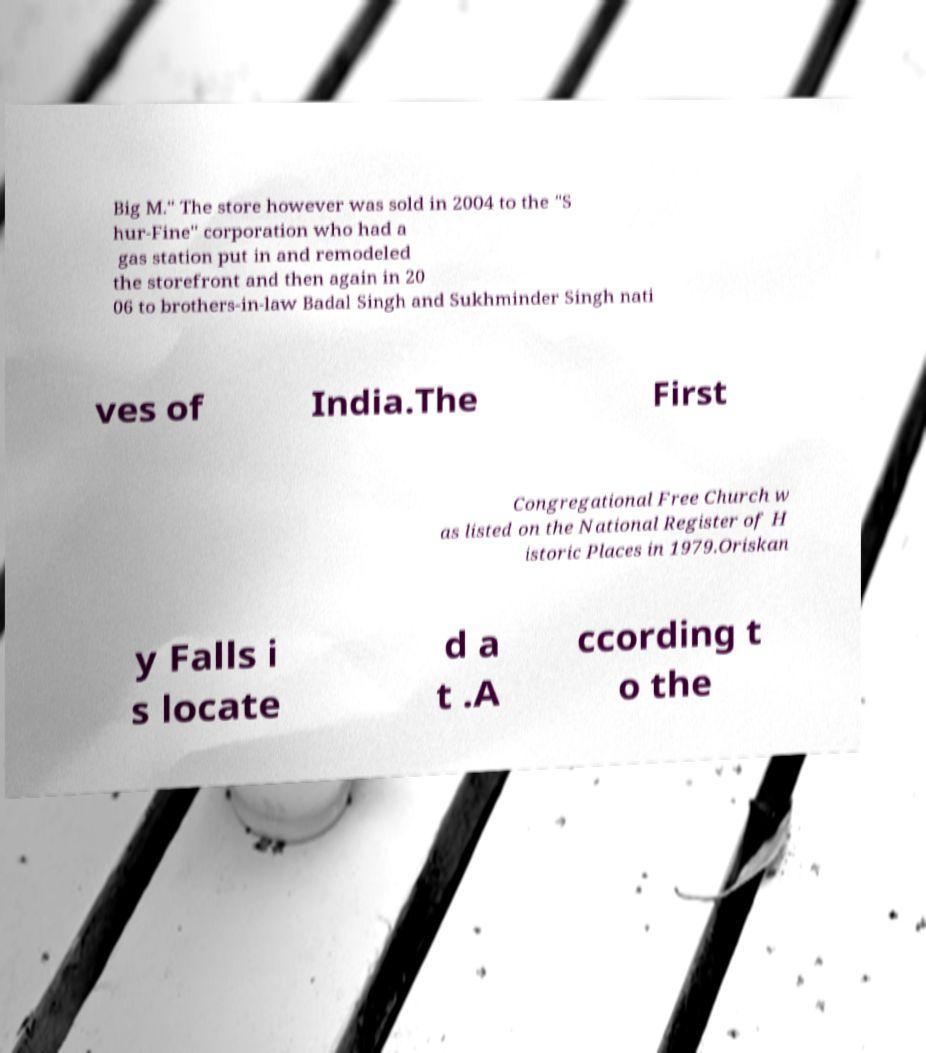What messages or text are displayed in this image? I need them in a readable, typed format. Big M." The store however was sold in 2004 to the "S hur-Fine" corporation who had a gas station put in and remodeled the storefront and then again in 20 06 to brothers-in-law Badal Singh and Sukhminder Singh nati ves of India.The First Congregational Free Church w as listed on the National Register of H istoric Places in 1979.Oriskan y Falls i s locate d a t .A ccording t o the 